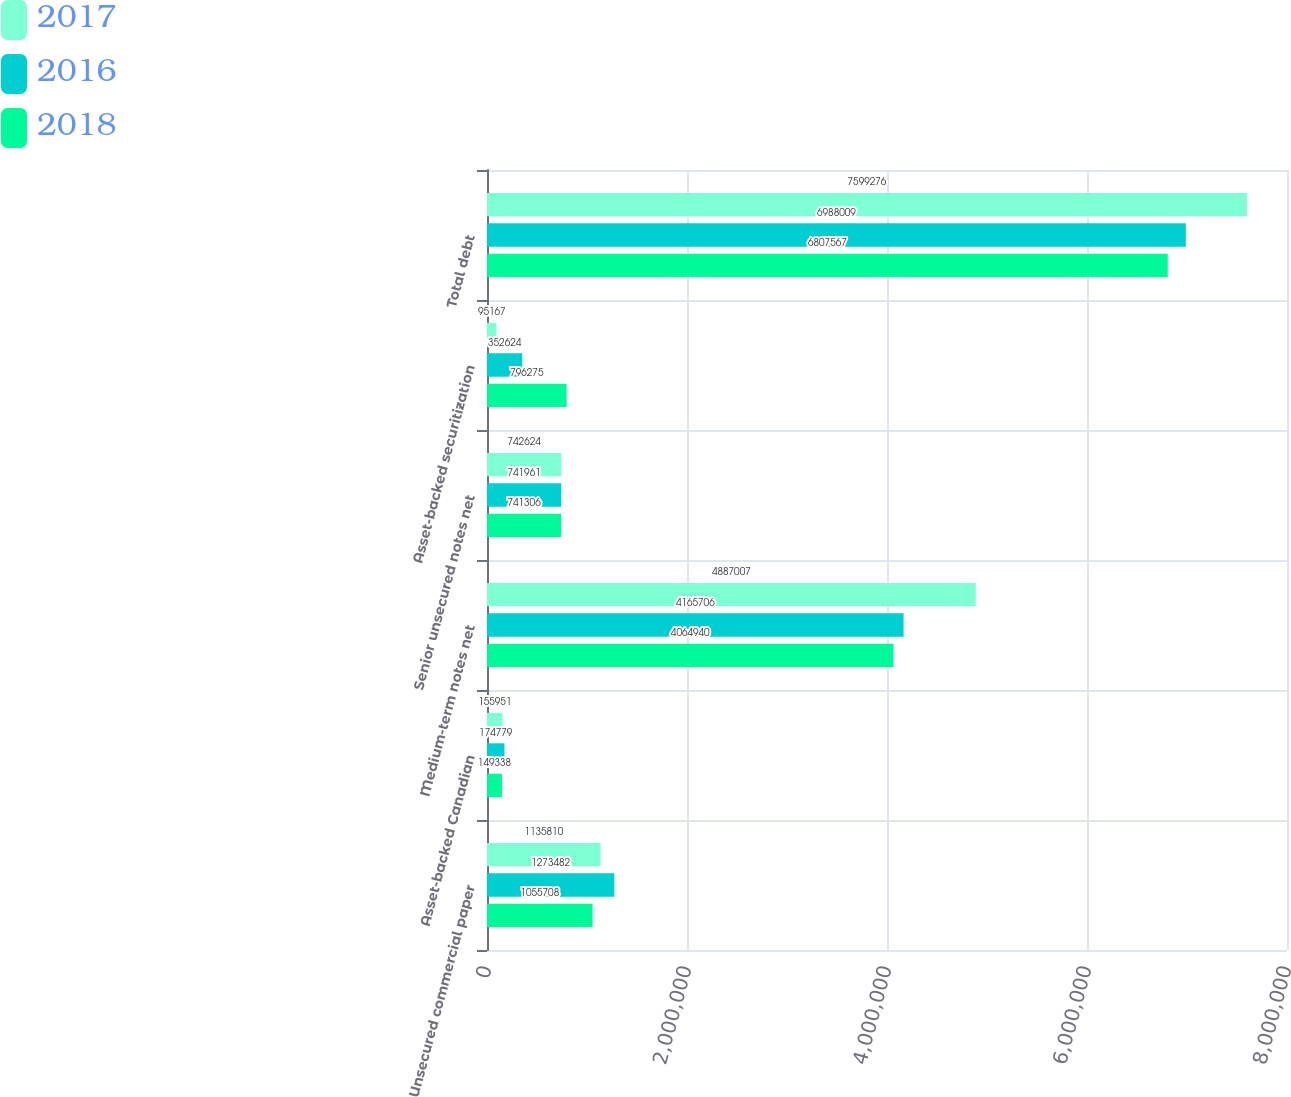Convert chart. <chart><loc_0><loc_0><loc_500><loc_500><stacked_bar_chart><ecel><fcel>Unsecured commercial paper<fcel>Asset-backed Canadian<fcel>Medium-term notes net<fcel>Senior unsecured notes net<fcel>Asset-backed securitization<fcel>Total debt<nl><fcel>2017<fcel>1.13581e+06<fcel>155951<fcel>4.88701e+06<fcel>742624<fcel>95167<fcel>7.59928e+06<nl><fcel>2016<fcel>1.27348e+06<fcel>174779<fcel>4.16571e+06<fcel>741961<fcel>352624<fcel>6.98801e+06<nl><fcel>2018<fcel>1.05571e+06<fcel>149338<fcel>4.06494e+06<fcel>741306<fcel>796275<fcel>6.80757e+06<nl></chart> 